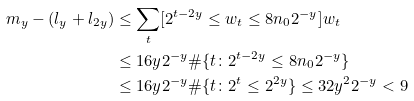<formula> <loc_0><loc_0><loc_500><loc_500>m _ { y } - ( l _ { y } + l _ { 2 y } ) & \leq \sum _ { t } [ 2 ^ { t - 2 y } \leq w _ { t } \leq 8 n _ { 0 } 2 ^ { - y } ] w _ { t } \\ & \leq 1 6 y 2 ^ { - y } \# \{ t \colon 2 ^ { t - 2 y } \leq 8 n _ { 0 } 2 ^ { - y } \} \\ & \leq 1 6 y 2 ^ { - y } \# \{ t \colon 2 ^ { t } \leq 2 ^ { 2 y } \} \leq 3 2 y ^ { 2 } 2 ^ { - y } < 9</formula> 